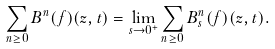<formula> <loc_0><loc_0><loc_500><loc_500>\sum _ { n \geq 0 } B ^ { n } ( f ) ( z , t ) = \lim _ { s \rightarrow 0 ^ { + } } \sum _ { n \geq 0 } B _ { s } ^ { n } ( f ) ( z , t ) .</formula> 